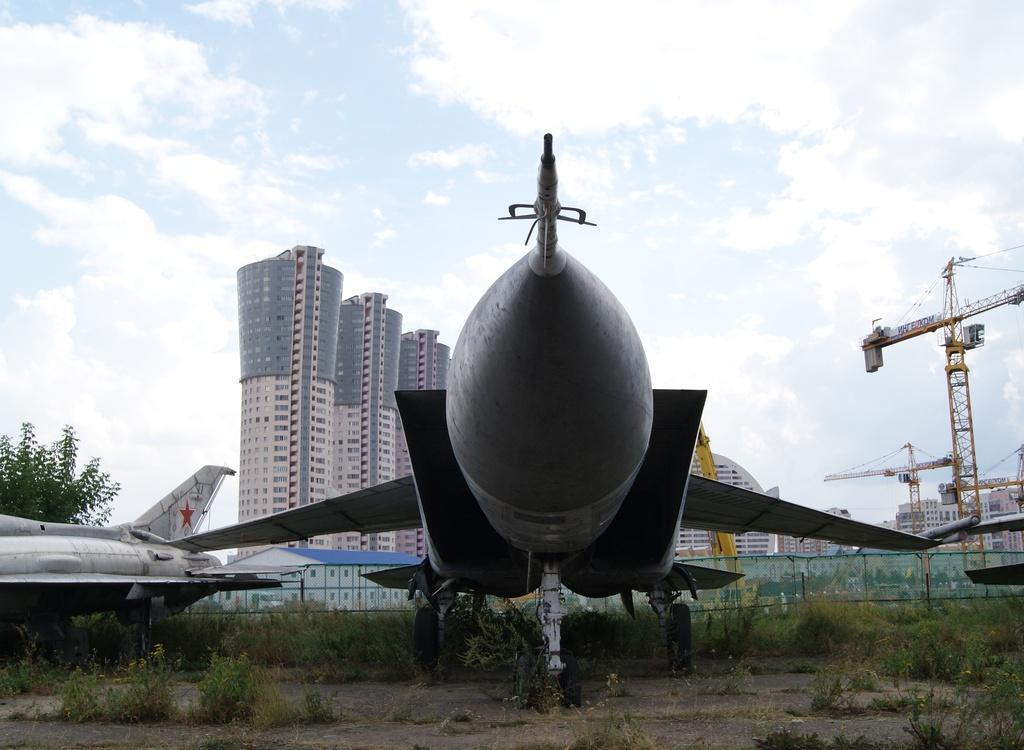How would you summarize this image in a sentence or two? In the picture we can see a sir craft which is parked on the path and near to it, we can see some plants and other aircraft beside it and in the background we can see some tower buildings and a sky with clouds. 